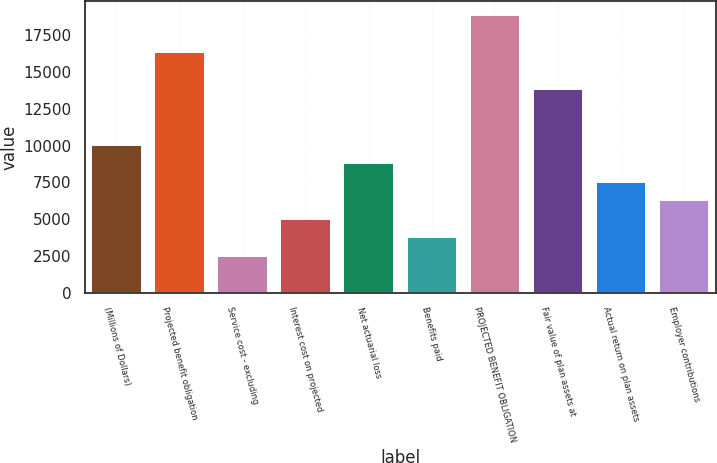<chart> <loc_0><loc_0><loc_500><loc_500><bar_chart><fcel>(Millions of Dollars)<fcel>Projected benefit obligation<fcel>Service cost - excluding<fcel>Interest cost on projected<fcel>Net actuarial loss<fcel>Benefits paid<fcel>PROJECTED BENEFIT OBLIGATION<fcel>Fair value of plan assets at<fcel>Actual return on plan assets<fcel>Employer contributions<nl><fcel>10059.6<fcel>16340.6<fcel>2522.4<fcel>5034.8<fcel>8803.4<fcel>3778.6<fcel>18853<fcel>13828.2<fcel>7547.2<fcel>6291<nl></chart> 